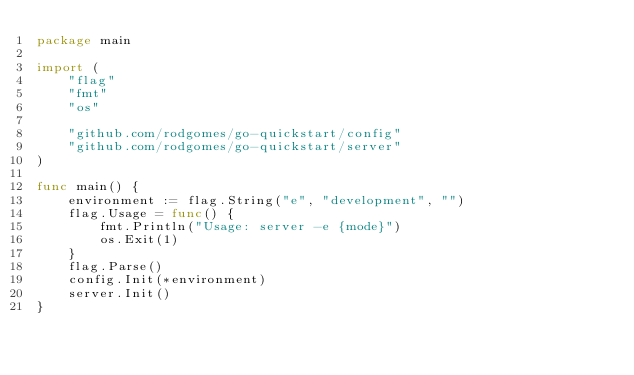<code> <loc_0><loc_0><loc_500><loc_500><_Go_>package main

import (
	"flag"
	"fmt"
	"os"

	"github.com/rodgomes/go-quickstart/config"
	"github.com/rodgomes/go-quickstart/server"
)

func main() {
	environment := flag.String("e", "development", "")
	flag.Usage = func() {
		fmt.Println("Usage: server -e {mode}")
		os.Exit(1)
	}
	flag.Parse()
	config.Init(*environment)
	server.Init()
}
</code> 